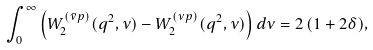<formula> <loc_0><loc_0><loc_500><loc_500>\int _ { 0 } ^ { \infty } \left ( W _ { 2 } ^ { ( \bar { \nu } p ) } ( q ^ { 2 } , \nu ) - W _ { 2 } ^ { ( \nu p ) } ( q ^ { 2 } , \nu ) \right ) d \nu = 2 \, ( 1 + 2 \delta ) ,</formula> 